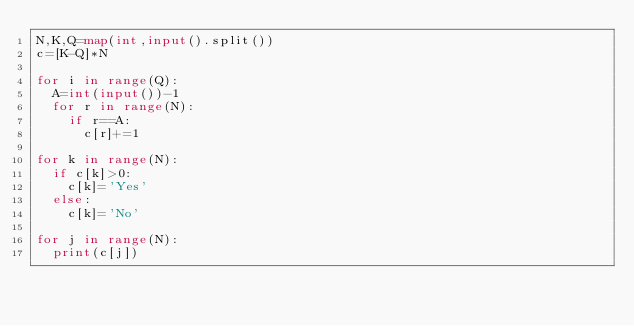Convert code to text. <code><loc_0><loc_0><loc_500><loc_500><_Python_>N,K,Q=map(int,input().split())
c=[K-Q]*N

for i in range(Q):
  A=int(input())-1
  for r in range(N):
    if r==A:
      c[r]+=1
    
for k in range(N):
  if c[k]>0:
    c[k]='Yes'
  else:
    c[k]='No'
    
for j in range(N):
  print(c[j])
    
    </code> 